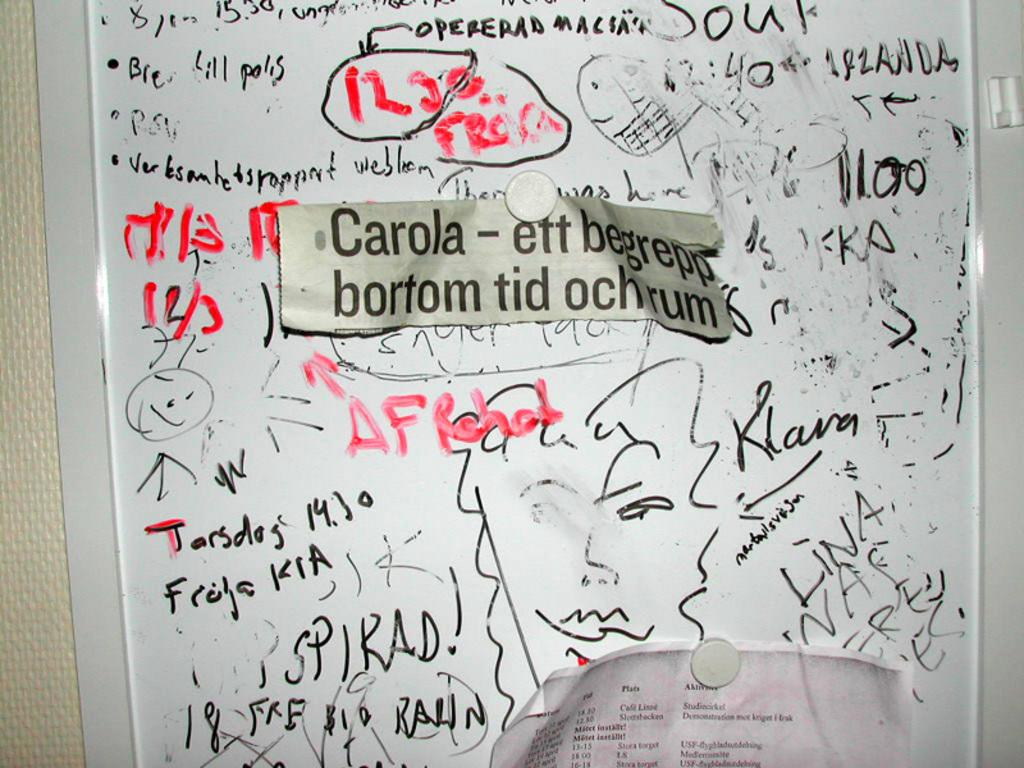<image>
Offer a succinct explanation of the picture presented. Bunch of wording on a markerboard and newspaper cut out that says Carola- ett begrepp bortom tid ochrum. 